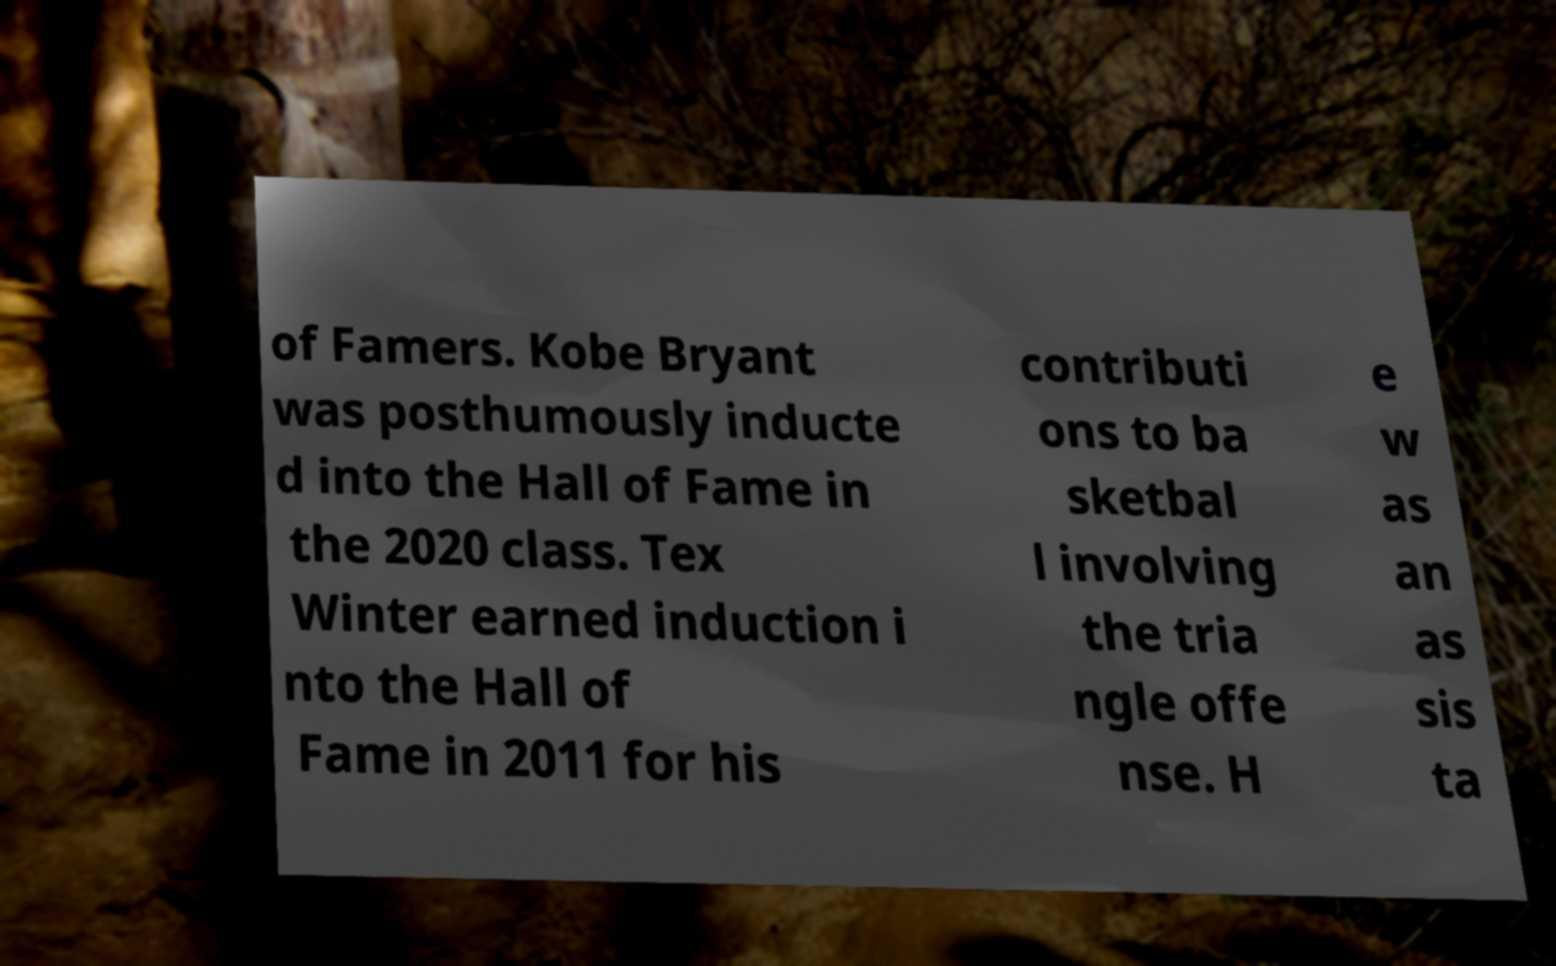Please identify and transcribe the text found in this image. of Famers. Kobe Bryant was posthumously inducte d into the Hall of Fame in the 2020 class. Tex Winter earned induction i nto the Hall of Fame in 2011 for his contributi ons to ba sketbal l involving the tria ngle offe nse. H e w as an as sis ta 